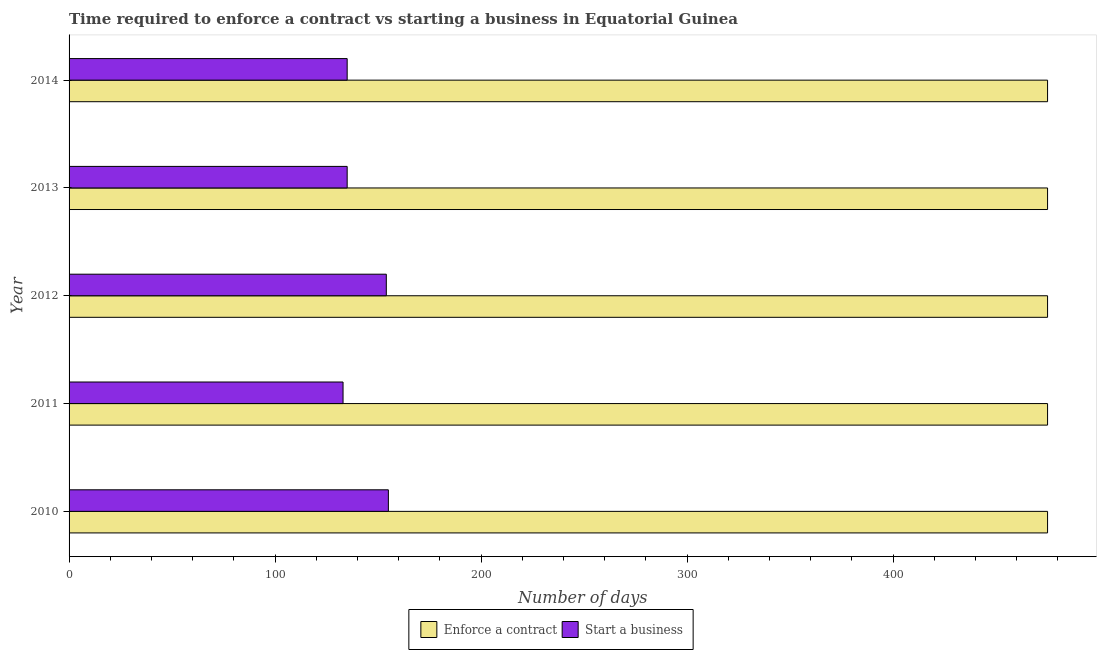How many groups of bars are there?
Ensure brevity in your answer.  5. Are the number of bars per tick equal to the number of legend labels?
Ensure brevity in your answer.  Yes. How many bars are there on the 2nd tick from the top?
Give a very brief answer. 2. What is the label of the 3rd group of bars from the top?
Your answer should be compact. 2012. What is the number of days to enforece a contract in 2011?
Make the answer very short. 475. Across all years, what is the maximum number of days to start a business?
Make the answer very short. 155. Across all years, what is the minimum number of days to enforece a contract?
Your response must be concise. 475. What is the total number of days to enforece a contract in the graph?
Provide a short and direct response. 2375. What is the difference between the number of days to start a business in 2010 and that in 2013?
Keep it short and to the point. 20. What is the difference between the number of days to enforece a contract in 2010 and the number of days to start a business in 2012?
Your response must be concise. 321. What is the average number of days to enforece a contract per year?
Your answer should be compact. 475. In the year 2012, what is the difference between the number of days to start a business and number of days to enforece a contract?
Your response must be concise. -321. In how many years, is the number of days to enforece a contract greater than 360 days?
Give a very brief answer. 5. Is the number of days to enforece a contract in 2010 less than that in 2014?
Your answer should be compact. No. What is the difference between the highest and the lowest number of days to start a business?
Give a very brief answer. 22. In how many years, is the number of days to start a business greater than the average number of days to start a business taken over all years?
Your answer should be very brief. 2. What does the 1st bar from the top in 2013 represents?
Offer a very short reply. Start a business. What does the 1st bar from the bottom in 2010 represents?
Ensure brevity in your answer.  Enforce a contract. How many bars are there?
Make the answer very short. 10. Are all the bars in the graph horizontal?
Offer a very short reply. Yes. What is the title of the graph?
Provide a succinct answer. Time required to enforce a contract vs starting a business in Equatorial Guinea. What is the label or title of the X-axis?
Offer a terse response. Number of days. What is the Number of days of Enforce a contract in 2010?
Your answer should be compact. 475. What is the Number of days in Start a business in 2010?
Give a very brief answer. 155. What is the Number of days of Enforce a contract in 2011?
Provide a short and direct response. 475. What is the Number of days in Start a business in 2011?
Give a very brief answer. 133. What is the Number of days of Enforce a contract in 2012?
Provide a succinct answer. 475. What is the Number of days of Start a business in 2012?
Your answer should be very brief. 154. What is the Number of days of Enforce a contract in 2013?
Offer a very short reply. 475. What is the Number of days in Start a business in 2013?
Your answer should be very brief. 135. What is the Number of days of Enforce a contract in 2014?
Make the answer very short. 475. What is the Number of days in Start a business in 2014?
Offer a terse response. 135. Across all years, what is the maximum Number of days in Enforce a contract?
Your response must be concise. 475. Across all years, what is the maximum Number of days of Start a business?
Your answer should be compact. 155. Across all years, what is the minimum Number of days of Enforce a contract?
Offer a terse response. 475. Across all years, what is the minimum Number of days of Start a business?
Make the answer very short. 133. What is the total Number of days of Enforce a contract in the graph?
Ensure brevity in your answer.  2375. What is the total Number of days in Start a business in the graph?
Make the answer very short. 712. What is the difference between the Number of days of Enforce a contract in 2010 and that in 2011?
Your answer should be very brief. 0. What is the difference between the Number of days of Start a business in 2010 and that in 2012?
Your answer should be compact. 1. What is the difference between the Number of days of Enforce a contract in 2010 and that in 2013?
Keep it short and to the point. 0. What is the difference between the Number of days in Start a business in 2010 and that in 2013?
Provide a short and direct response. 20. What is the difference between the Number of days in Enforce a contract in 2010 and that in 2014?
Offer a terse response. 0. What is the difference between the Number of days of Enforce a contract in 2011 and that in 2012?
Offer a very short reply. 0. What is the difference between the Number of days in Start a business in 2011 and that in 2012?
Your answer should be compact. -21. What is the difference between the Number of days in Enforce a contract in 2011 and that in 2013?
Your answer should be compact. 0. What is the difference between the Number of days of Start a business in 2011 and that in 2013?
Give a very brief answer. -2. What is the difference between the Number of days of Start a business in 2011 and that in 2014?
Give a very brief answer. -2. What is the difference between the Number of days in Enforce a contract in 2012 and that in 2013?
Offer a very short reply. 0. What is the difference between the Number of days of Start a business in 2012 and that in 2013?
Make the answer very short. 19. What is the difference between the Number of days in Enforce a contract in 2012 and that in 2014?
Provide a short and direct response. 0. What is the difference between the Number of days of Start a business in 2012 and that in 2014?
Your response must be concise. 19. What is the difference between the Number of days of Enforce a contract in 2013 and that in 2014?
Your response must be concise. 0. What is the difference between the Number of days in Start a business in 2013 and that in 2014?
Your answer should be compact. 0. What is the difference between the Number of days in Enforce a contract in 2010 and the Number of days in Start a business in 2011?
Give a very brief answer. 342. What is the difference between the Number of days in Enforce a contract in 2010 and the Number of days in Start a business in 2012?
Provide a short and direct response. 321. What is the difference between the Number of days in Enforce a contract in 2010 and the Number of days in Start a business in 2013?
Your answer should be compact. 340. What is the difference between the Number of days in Enforce a contract in 2010 and the Number of days in Start a business in 2014?
Provide a succinct answer. 340. What is the difference between the Number of days in Enforce a contract in 2011 and the Number of days in Start a business in 2012?
Offer a terse response. 321. What is the difference between the Number of days in Enforce a contract in 2011 and the Number of days in Start a business in 2013?
Provide a succinct answer. 340. What is the difference between the Number of days of Enforce a contract in 2011 and the Number of days of Start a business in 2014?
Provide a short and direct response. 340. What is the difference between the Number of days in Enforce a contract in 2012 and the Number of days in Start a business in 2013?
Provide a succinct answer. 340. What is the difference between the Number of days in Enforce a contract in 2012 and the Number of days in Start a business in 2014?
Provide a short and direct response. 340. What is the difference between the Number of days of Enforce a contract in 2013 and the Number of days of Start a business in 2014?
Provide a short and direct response. 340. What is the average Number of days of Enforce a contract per year?
Provide a succinct answer. 475. What is the average Number of days of Start a business per year?
Offer a terse response. 142.4. In the year 2010, what is the difference between the Number of days in Enforce a contract and Number of days in Start a business?
Offer a very short reply. 320. In the year 2011, what is the difference between the Number of days of Enforce a contract and Number of days of Start a business?
Your response must be concise. 342. In the year 2012, what is the difference between the Number of days in Enforce a contract and Number of days in Start a business?
Your answer should be compact. 321. In the year 2013, what is the difference between the Number of days of Enforce a contract and Number of days of Start a business?
Give a very brief answer. 340. In the year 2014, what is the difference between the Number of days in Enforce a contract and Number of days in Start a business?
Ensure brevity in your answer.  340. What is the ratio of the Number of days in Enforce a contract in 2010 to that in 2011?
Offer a very short reply. 1. What is the ratio of the Number of days in Start a business in 2010 to that in 2011?
Provide a short and direct response. 1.17. What is the ratio of the Number of days of Enforce a contract in 2010 to that in 2012?
Offer a terse response. 1. What is the ratio of the Number of days in Start a business in 2010 to that in 2012?
Provide a succinct answer. 1.01. What is the ratio of the Number of days in Enforce a contract in 2010 to that in 2013?
Give a very brief answer. 1. What is the ratio of the Number of days of Start a business in 2010 to that in 2013?
Provide a short and direct response. 1.15. What is the ratio of the Number of days of Start a business in 2010 to that in 2014?
Make the answer very short. 1.15. What is the ratio of the Number of days of Enforce a contract in 2011 to that in 2012?
Give a very brief answer. 1. What is the ratio of the Number of days in Start a business in 2011 to that in 2012?
Make the answer very short. 0.86. What is the ratio of the Number of days of Start a business in 2011 to that in 2013?
Ensure brevity in your answer.  0.99. What is the ratio of the Number of days of Start a business in 2011 to that in 2014?
Your answer should be compact. 0.99. What is the ratio of the Number of days of Enforce a contract in 2012 to that in 2013?
Keep it short and to the point. 1. What is the ratio of the Number of days in Start a business in 2012 to that in 2013?
Your answer should be very brief. 1.14. What is the ratio of the Number of days of Start a business in 2012 to that in 2014?
Give a very brief answer. 1.14. What is the ratio of the Number of days in Start a business in 2013 to that in 2014?
Your answer should be very brief. 1. What is the difference between the highest and the second highest Number of days in Start a business?
Make the answer very short. 1. What is the difference between the highest and the lowest Number of days in Enforce a contract?
Provide a short and direct response. 0. 